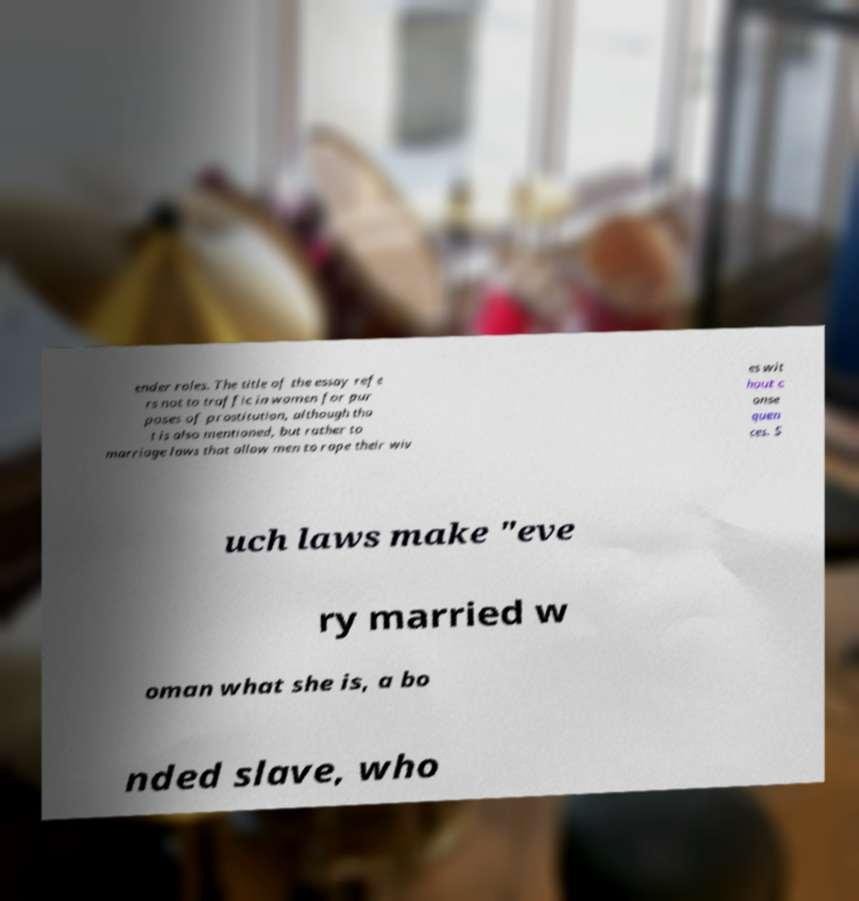Please read and relay the text visible in this image. What does it say? ender roles. The title of the essay refe rs not to traffic in women for pur poses of prostitution, although tha t is also mentioned, but rather to marriage laws that allow men to rape their wiv es wit hout c onse quen ces. S uch laws make "eve ry married w oman what she is, a bo nded slave, who 